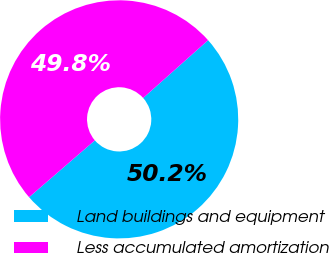Convert chart. <chart><loc_0><loc_0><loc_500><loc_500><pie_chart><fcel>Land buildings and equipment<fcel>Less accumulated amortization<nl><fcel>50.23%<fcel>49.77%<nl></chart> 